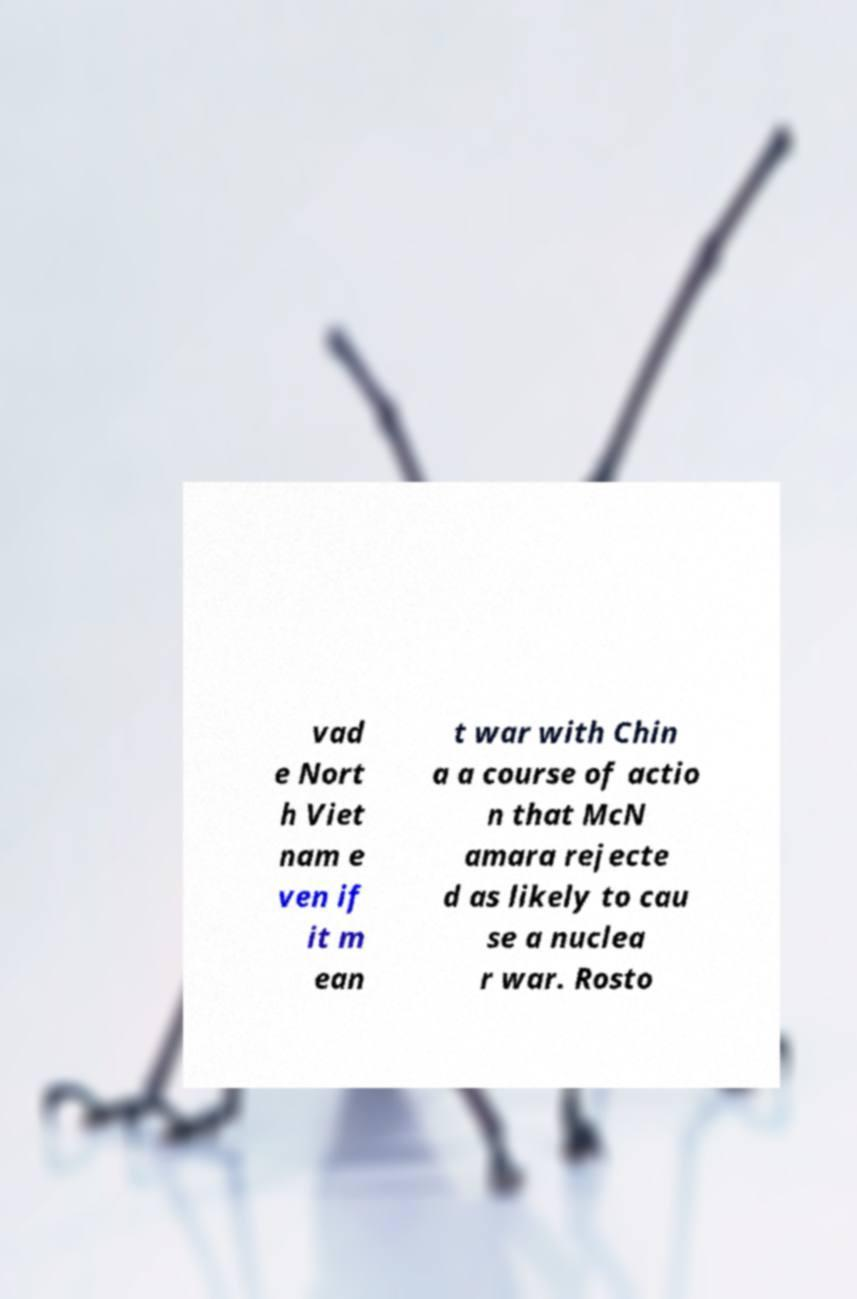Can you read and provide the text displayed in the image?This photo seems to have some interesting text. Can you extract and type it out for me? vad e Nort h Viet nam e ven if it m ean t war with Chin a a course of actio n that McN amara rejecte d as likely to cau se a nuclea r war. Rosto 